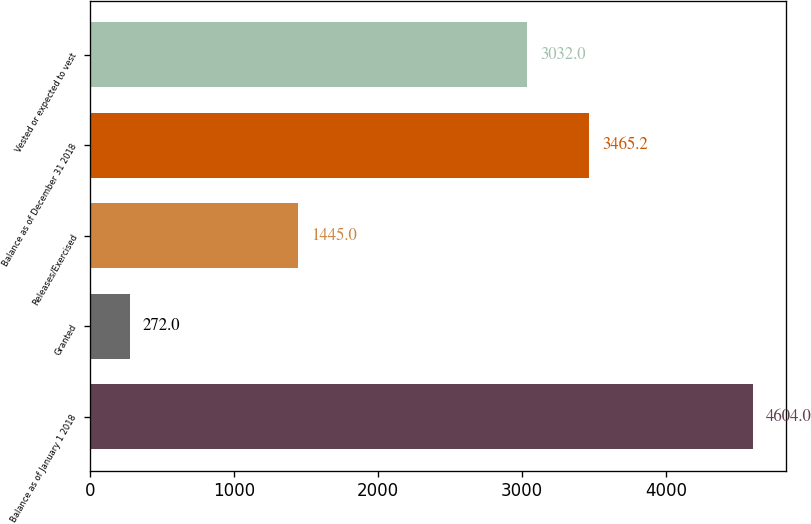<chart> <loc_0><loc_0><loc_500><loc_500><bar_chart><fcel>Balance as of January 1 2018<fcel>Granted<fcel>Releases/Exercised<fcel>Balance as of December 31 2018<fcel>Vested or expected to vest<nl><fcel>4604<fcel>272<fcel>1445<fcel>3465.2<fcel>3032<nl></chart> 